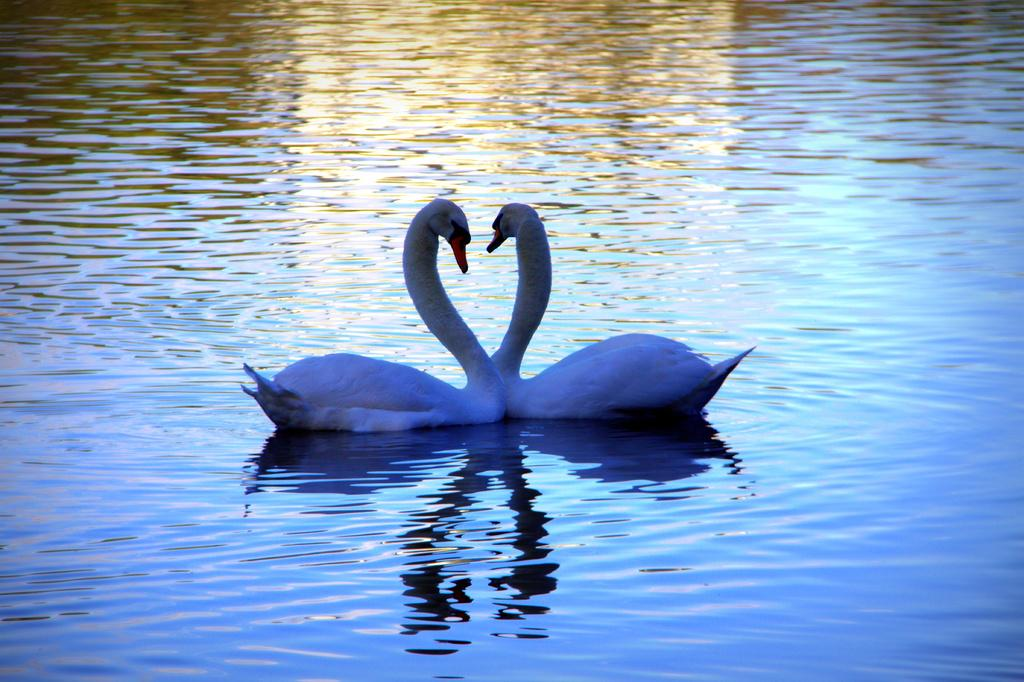What animals are present in the image? There are two swans in the image. Where are the swans located? The swans are in the water. What type of wind can be seen affecting the swans in the image? There is no wind present in the image; the swans are simply in the water. 